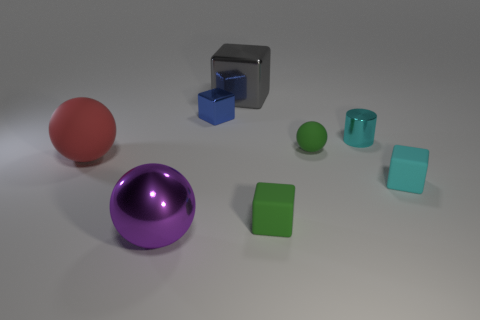Is the color of the small rubber object to the right of the small cyan metal thing the same as the small block behind the small cylinder?
Keep it short and to the point. No. The object that is the same color as the cylinder is what shape?
Offer a terse response. Cube. How many metallic objects are either big things or small balls?
Your answer should be compact. 2. The tiny matte thing that is on the right side of the ball that is to the right of the sphere in front of the small green matte cube is what color?
Your response must be concise. Cyan. What is the color of the small rubber object that is the same shape as the big red object?
Your answer should be compact. Green. Are there any other things that have the same color as the metallic cylinder?
Ensure brevity in your answer.  Yes. How many other objects are there of the same material as the tiny ball?
Your answer should be compact. 3. The gray shiny cube is what size?
Your response must be concise. Large. Are there any other big shiny objects that have the same shape as the large gray metallic thing?
Provide a short and direct response. No. How many things are either big green objects or large objects behind the metal cylinder?
Ensure brevity in your answer.  1. 